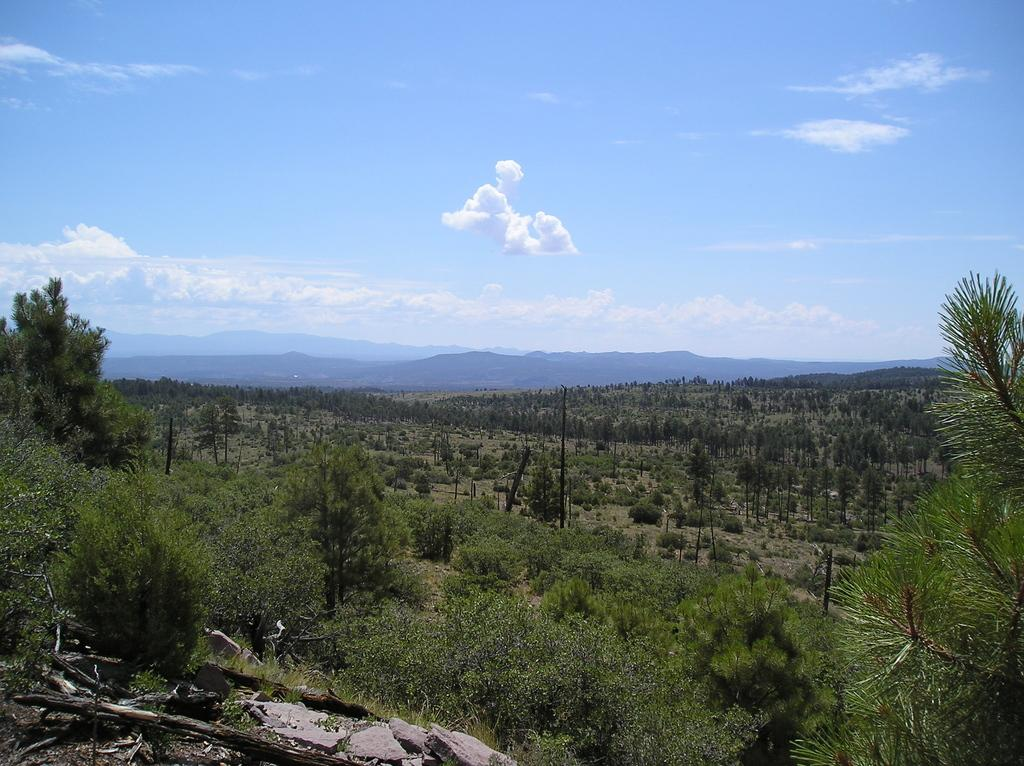What type of vegetation is visible in the image? There are trees in the image. What structures can be seen in the image? There are poles in the image. What type of natural landform is present in the image? There are hills in the image. What can be seen in the sky in the image? There are clouds in the image. What type of nut can be seen growing on the trees in the image? There is no nut visible on the trees in the image. On which side of the image are the hills located? The image does not specify the side on which the hills are located. What letters can be seen on the poles in the image? The image does not show any letters on the poles. 